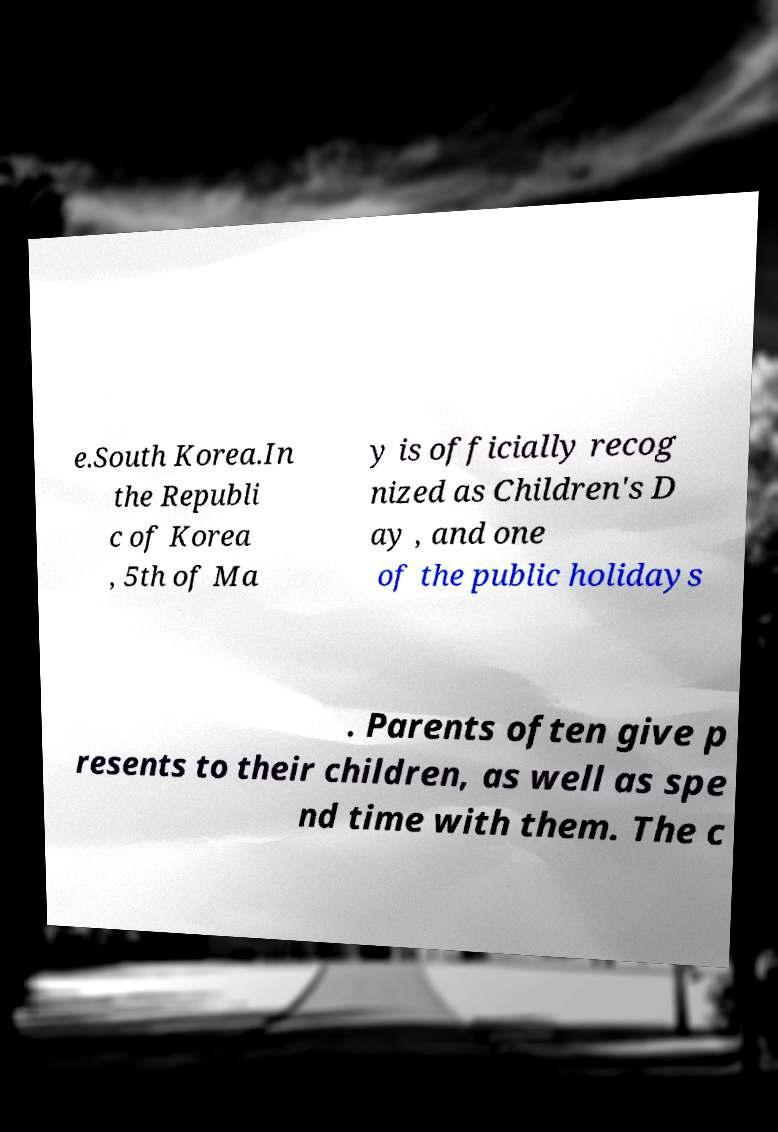I need the written content from this picture converted into text. Can you do that? e.South Korea.In the Republi c of Korea , 5th of Ma y is officially recog nized as Children's D ay , and one of the public holidays . Parents often give p resents to their children, as well as spe nd time with them. The c 